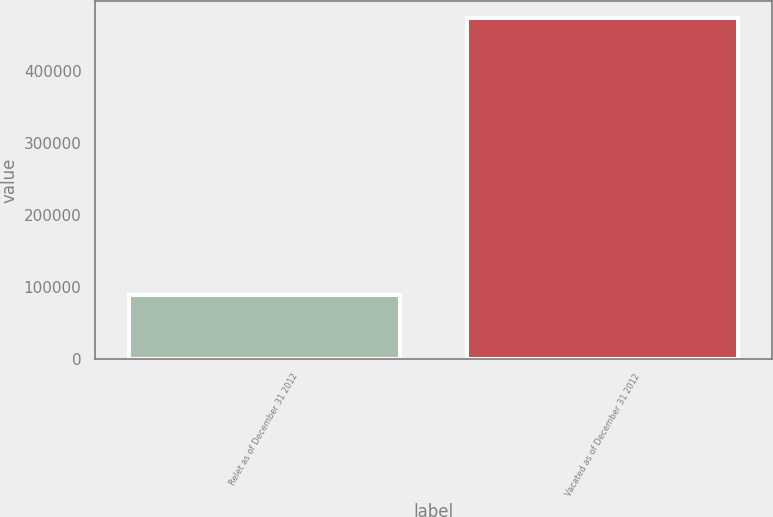<chart> <loc_0><loc_0><loc_500><loc_500><bar_chart><fcel>Relet as of December 31 2012<fcel>Vacated as of December 31 2012<nl><fcel>88000<fcel>473000<nl></chart> 